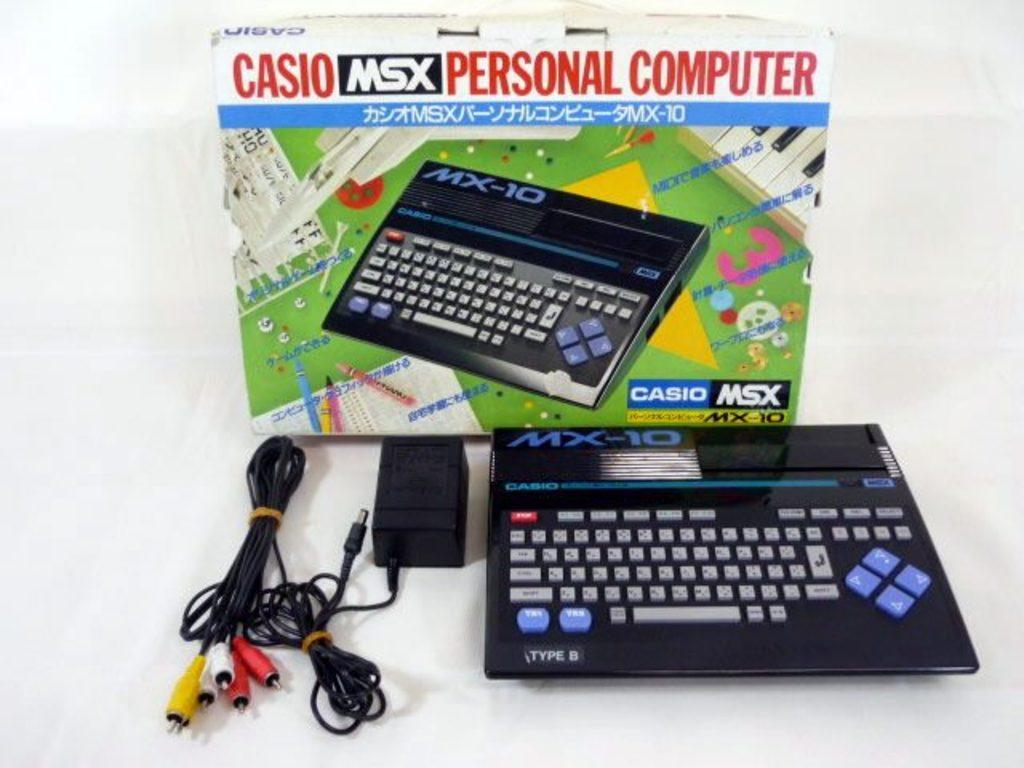<image>
Summarize the visual content of the image. A Casio Msx Personal Computer is displayed with its cords in front of the box. 